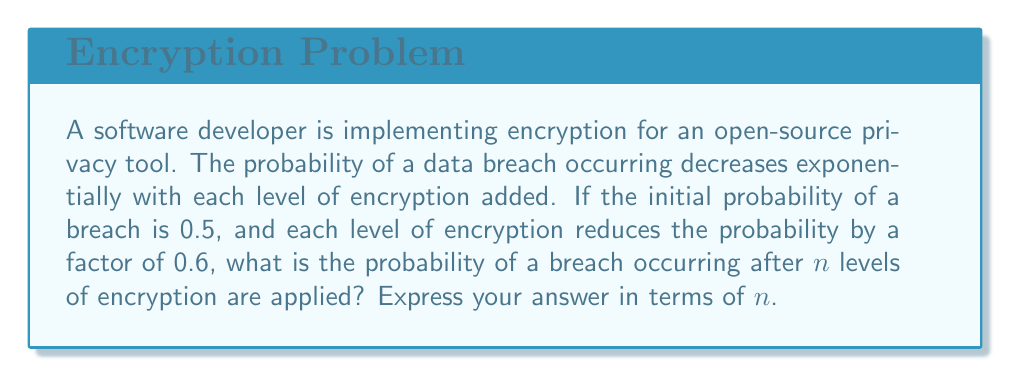Solve this math problem. Let's approach this step-by-step:

1) The initial probability of a breach is 0.5.

2) Each level of encryption reduces the probability by a factor of 0.6. This means that after each level, we multiply the previous probability by 0.6.

3) We can express this as a geometric sequence:

   $$a_n = 0.5 \cdot (0.6)^n$$

   Where $a_n$ is the probability after $n$ levels of encryption.

4) This is because:
   - After 1 level: $0.5 \cdot 0.6$
   - After 2 levels: $0.5 \cdot 0.6 \cdot 0.6 = 0.5 \cdot (0.6)^2$
   - After 3 levels: $0.5 \cdot 0.6 \cdot 0.6 \cdot 0.6 = 0.5 \cdot (0.6)^3$
   
   And so on...

5) Therefore, the general term for the probability after $n$ levels is:

   $$P(breach) = 0.5 \cdot (0.6)^n$$

This formula gives us the probability of a breach occurring after $n$ levels of encryption are applied.
Answer: $0.5 \cdot (0.6)^n$ 